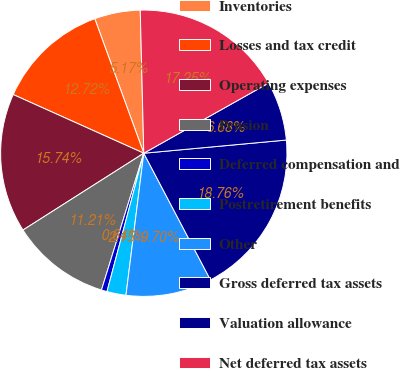<chart> <loc_0><loc_0><loc_500><loc_500><pie_chart><fcel>Inventories<fcel>Losses and tax credit<fcel>Operating expenses<fcel>Pension<fcel>Deferred compensation and<fcel>Postretirement benefits<fcel>Other<fcel>Gross deferred tax assets<fcel>Valuation allowance<fcel>Net deferred tax assets<nl><fcel>5.17%<fcel>12.72%<fcel>15.74%<fcel>11.21%<fcel>0.64%<fcel>2.15%<fcel>9.7%<fcel>18.76%<fcel>6.68%<fcel>17.25%<nl></chart> 